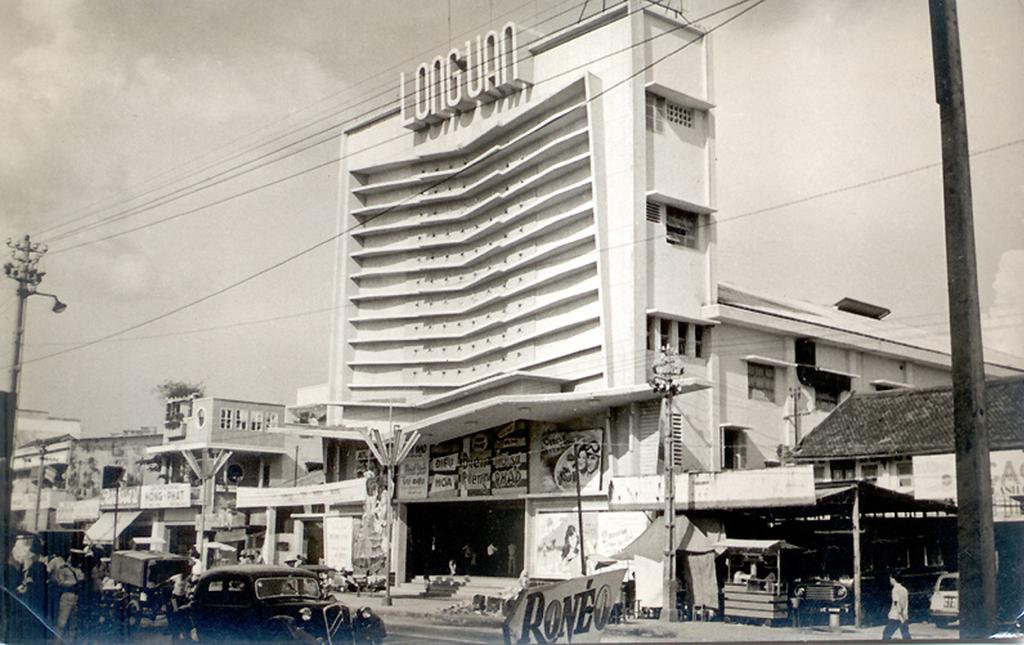What is the main subject of the image? The main subject of the image is a car on the road. Are there any other vehicles present in the image? Yes, there are other vehicles on the road in the image. What can be seen in the background of the image? In the background of the image, there are buildings, wires, a pole, and the sky. How many chickens are crossing the road in the image? There are no chickens present in the image; it features a car and other vehicles on the road. What type of society is depicted in the image? The image does not depict a society; it shows a car and other vehicles on a road with buildings and other elements in the background. 